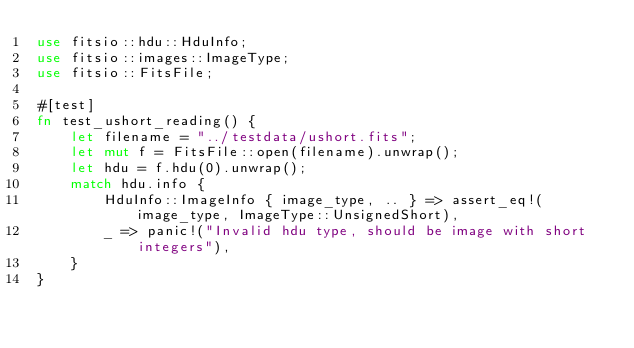<code> <loc_0><loc_0><loc_500><loc_500><_Rust_>use fitsio::hdu::HduInfo;
use fitsio::images::ImageType;
use fitsio::FitsFile;

#[test]
fn test_ushort_reading() {
    let filename = "../testdata/ushort.fits";
    let mut f = FitsFile::open(filename).unwrap();
    let hdu = f.hdu(0).unwrap();
    match hdu.info {
        HduInfo::ImageInfo { image_type, .. } => assert_eq!(image_type, ImageType::UnsignedShort),
        _ => panic!("Invalid hdu type, should be image with short integers"),
    }
}
</code> 